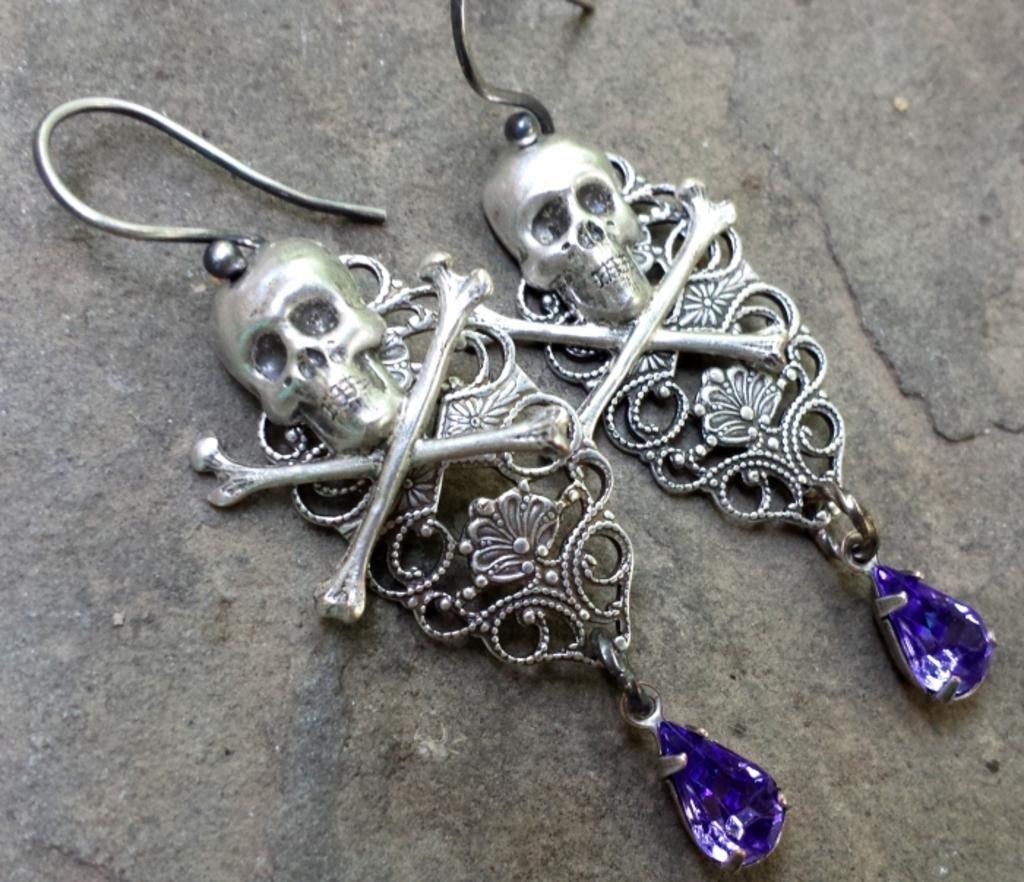Can you describe this image briefly? In the image we can see earrings present on the floor. 